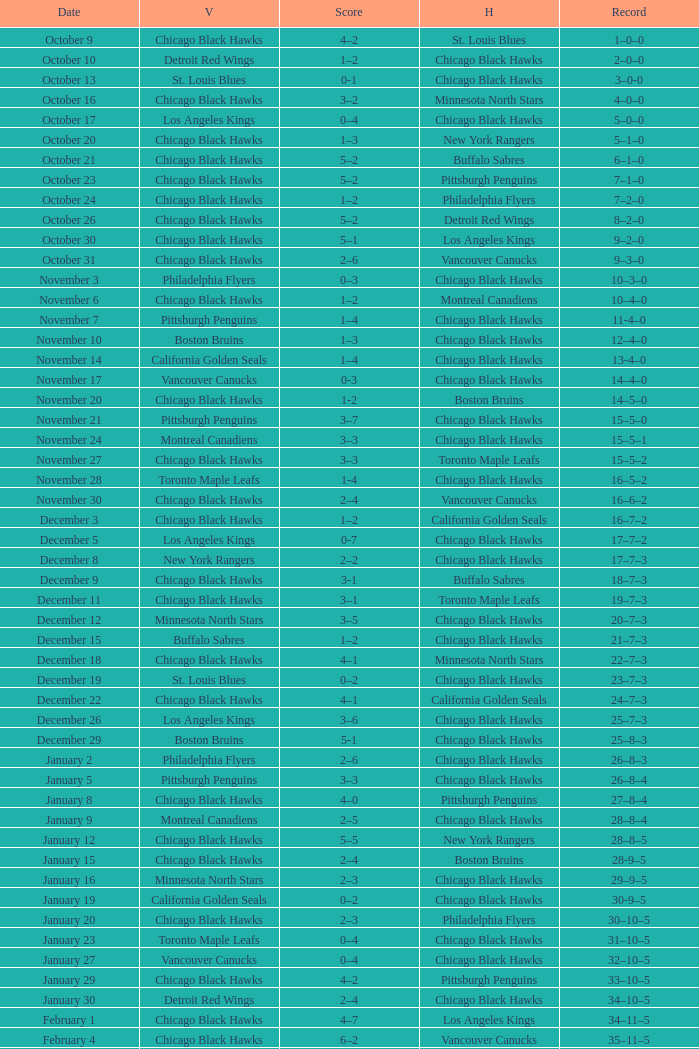What is the Record of the February 26 date? 39–16–7. 